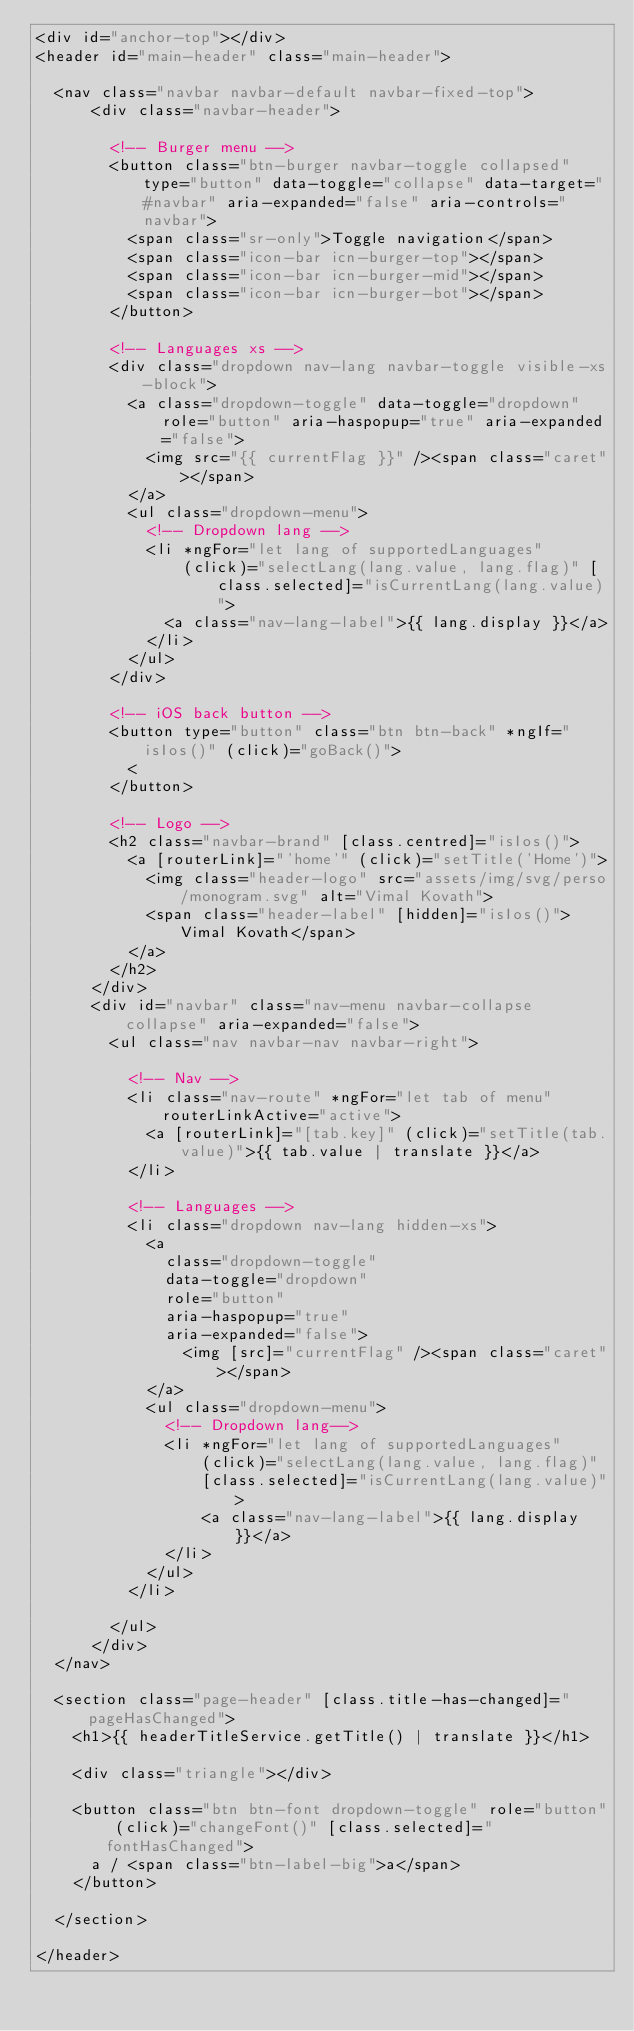Convert code to text. <code><loc_0><loc_0><loc_500><loc_500><_HTML_><div id="anchor-top"></div>
<header id="main-header" class="main-header">

  <nav class="navbar navbar-default navbar-fixed-top">
      <div class="navbar-header">

        <!-- Burger menu -->
        <button class="btn-burger navbar-toggle collapsed" type="button" data-toggle="collapse" data-target="#navbar" aria-expanded="false" aria-controls="navbar">
          <span class="sr-only">Toggle navigation</span>
          <span class="icon-bar icn-burger-top"></span>
          <span class="icon-bar icn-burger-mid"></span>
          <span class="icon-bar icn-burger-bot"></span>
        </button>

        <!-- Languages xs -->
        <div class="dropdown nav-lang navbar-toggle visible-xs-block">
          <a class="dropdown-toggle" data-toggle="dropdown" role="button" aria-haspopup="true" aria-expanded="false">
            <img src="{{ currentFlag }}" /><span class="caret"></span>
          </a>
          <ul class="dropdown-menu">
            <!-- Dropdown lang -->
            <li *ngFor="let lang of supportedLanguages"
                (click)="selectLang(lang.value, lang.flag)" [class.selected]="isCurrentLang(lang.value)">
              <a class="nav-lang-label">{{ lang.display }}</a>
            </li>
          </ul>
        </div>

        <!-- iOS back button -->
        <button type="button" class="btn btn-back" *ngIf="isIos()" (click)="goBack()">
          <
        </button>

        <!-- Logo -->
        <h2 class="navbar-brand" [class.centred]="isIos()">
          <a [routerLink]="'home'" (click)="setTitle('Home')">
            <img class="header-logo" src="assets/img/svg/perso/monogram.svg" alt="Vimal Kovath">
            <span class="header-label" [hidden]="isIos()">Vimal Kovath</span>
          </a>
        </h2>
      </div>
      <div id="navbar" class="nav-menu navbar-collapse collapse" aria-expanded="false">
        <ul class="nav navbar-nav navbar-right">

          <!-- Nav -->
          <li class="nav-route" *ngFor="let tab of menu" routerLinkActive="active">
            <a [routerLink]="[tab.key]" (click)="setTitle(tab.value)">{{ tab.value | translate }}</a>
          </li>

          <!-- Languages -->
          <li class="dropdown nav-lang hidden-xs">
            <a
              class="dropdown-toggle"
              data-toggle="dropdown"
              role="button"
              aria-haspopup="true"
              aria-expanded="false">
                <img [src]="currentFlag" /><span class="caret"></span>
            </a>
            <ul class="dropdown-menu">
              <!-- Dropdown lang-->
              <li *ngFor="let lang of supportedLanguages"
                  (click)="selectLang(lang.value, lang.flag)"
                  [class.selected]="isCurrentLang(lang.value)">
                  <a class="nav-lang-label">{{ lang.display }}</a>
              </li>
            </ul>
          </li>

        </ul>
      </div>
  </nav>

  <section class="page-header" [class.title-has-changed]="pageHasChanged">
    <h1>{{ headerTitleService.getTitle() | translate }}</h1>

    <div class="triangle"></div>

    <button class="btn btn-font dropdown-toggle" role="button" (click)="changeFont()" [class.selected]="fontHasChanged">
      a / <span class="btn-label-big">a</span>
    </button>

  </section>

</header>
</code> 